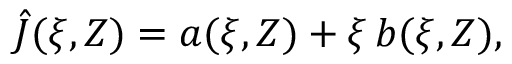<formula> <loc_0><loc_0><loc_500><loc_500>\hat { J } ( \xi , Z ) = a ( \xi , Z ) + \xi \, b ( \xi , Z ) ,</formula> 